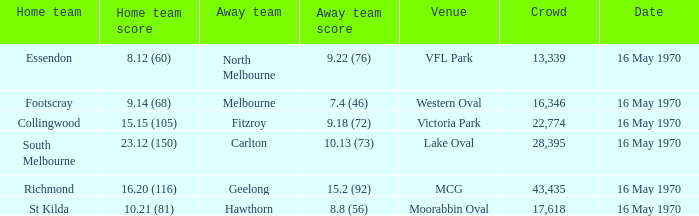Who was the away team at western oval? Melbourne. 